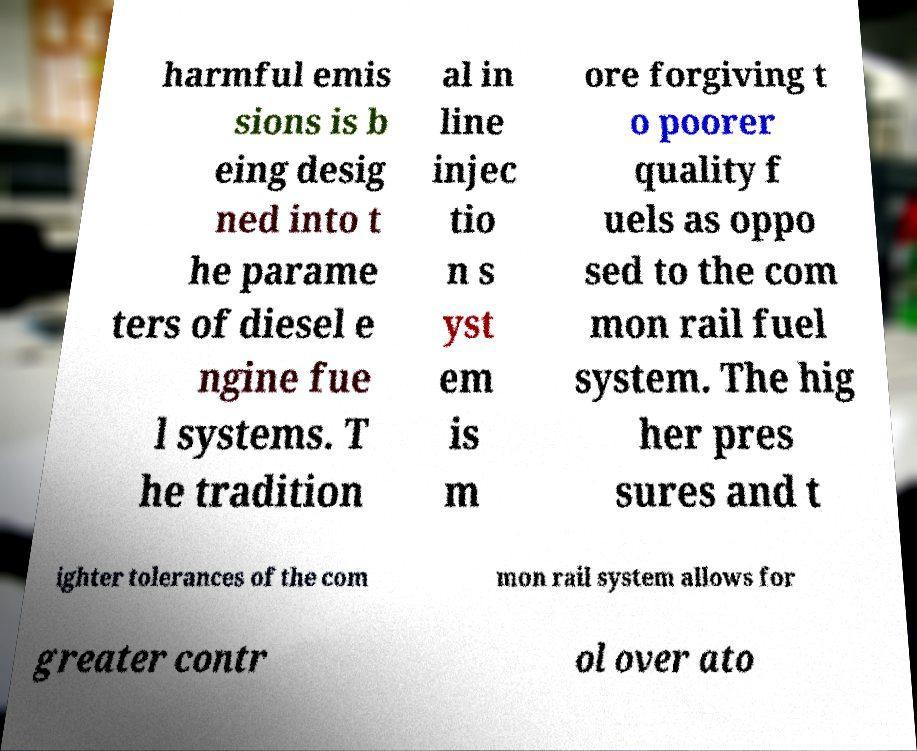Could you assist in decoding the text presented in this image and type it out clearly? harmful emis sions is b eing desig ned into t he parame ters of diesel e ngine fue l systems. T he tradition al in line injec tio n s yst em is m ore forgiving t o poorer quality f uels as oppo sed to the com mon rail fuel system. The hig her pres sures and t ighter tolerances of the com mon rail system allows for greater contr ol over ato 